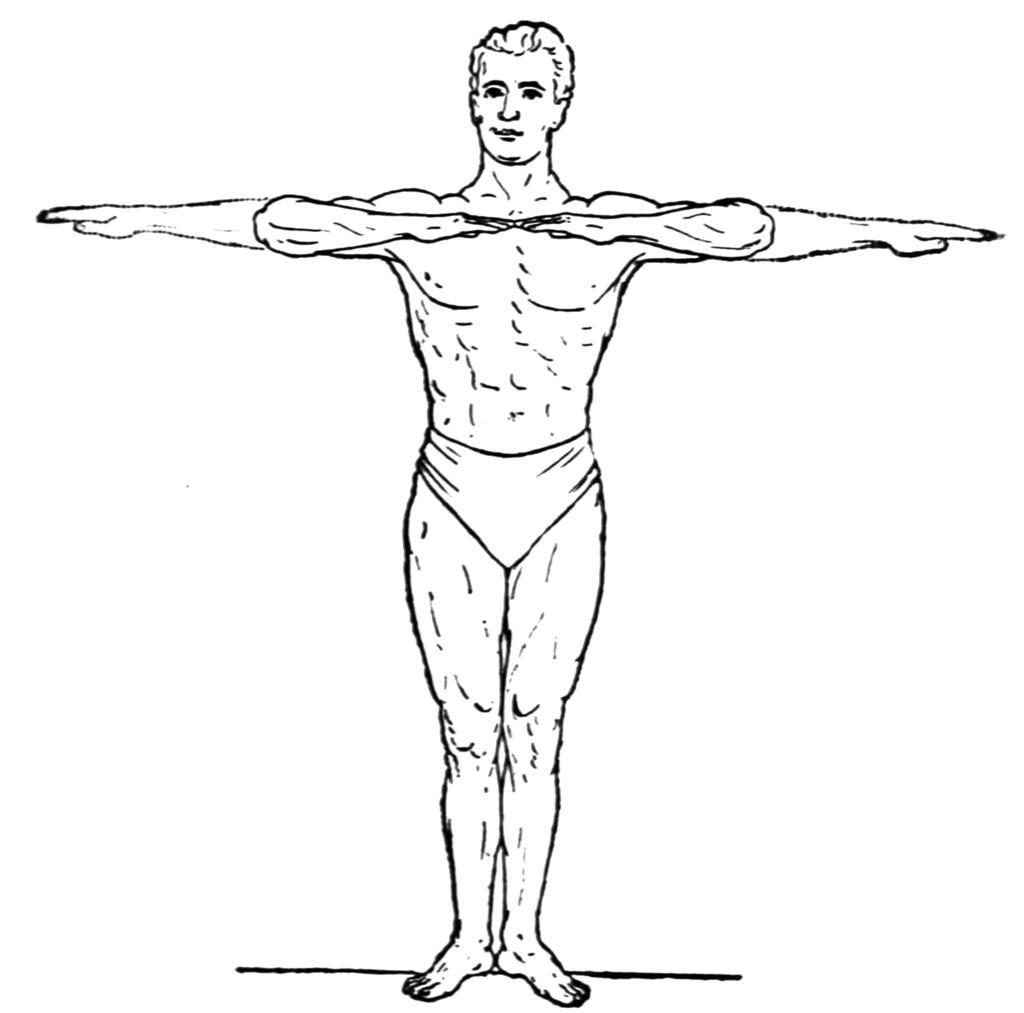In one or two sentences, can you explain what this image depicts? In the picture we can see a diagram of a man standing and doing a exercise. 